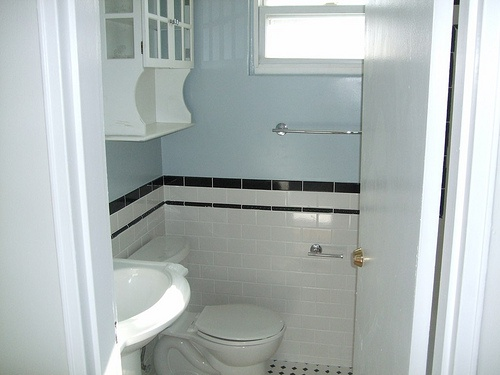Describe the objects in this image and their specific colors. I can see toilet in darkgray and gray tones and sink in darkgray and lightgray tones in this image. 